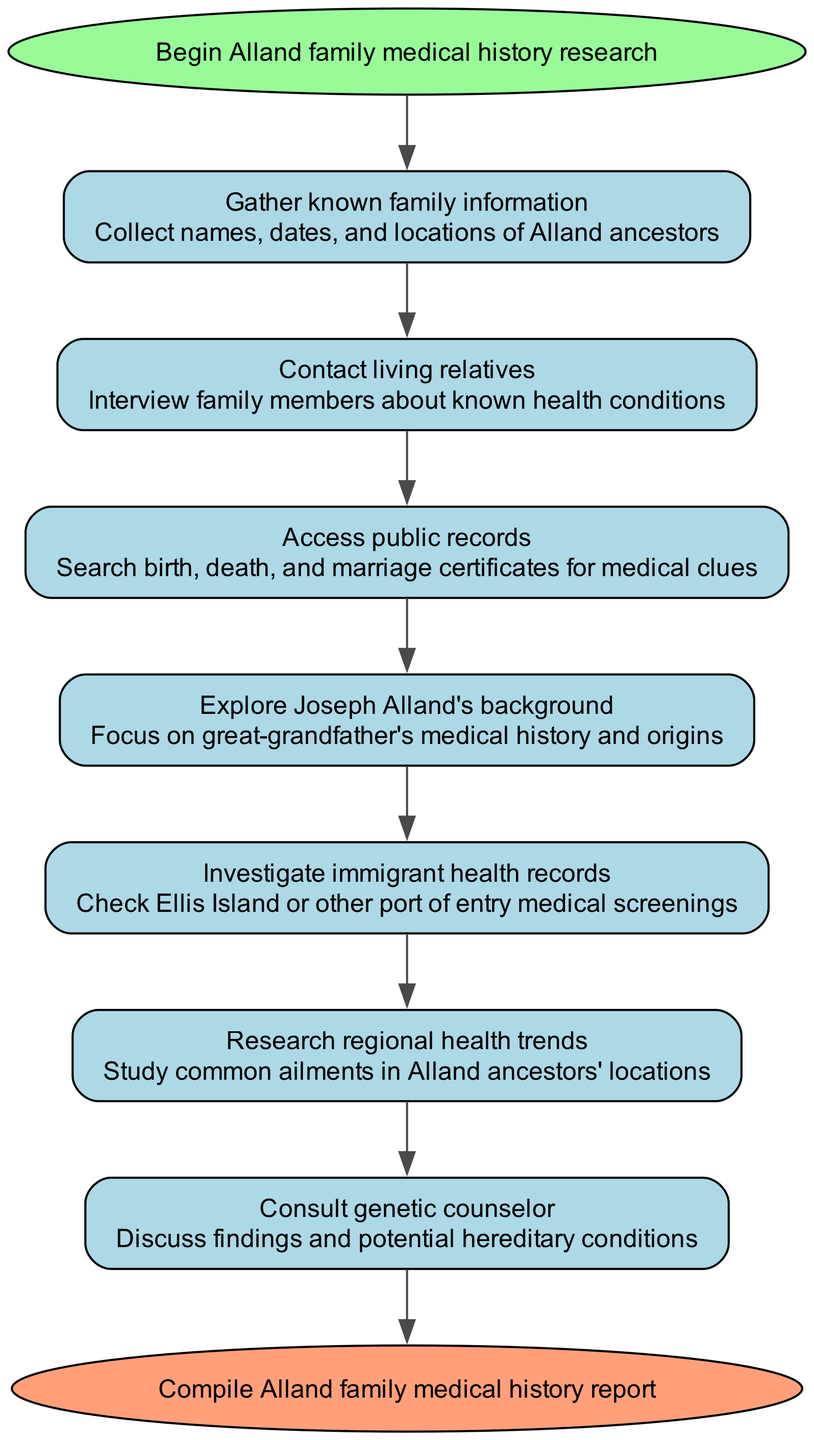What is the first step in the Alland family medical history research? The first step in the research as indicated in the diagram is "Gather known family information." This is the step that directly follows the start node of the pathway.
Answer: Gather known family information How many steps are there in total in the diagram? Counting the steps listed in the diagram, there are a total of 7 steps between the start and end nodes, not including the start and end nodes themselves.
Answer: 7 What step involves interviewing family members? The step that involves interviewing family members is "Contact living relatives," which is specifically detailed to gather information on known health conditions. This step is connected to the previous step of gathering known family information.
Answer: Contact living relatives What is the last step before compiling the medical history report? The last step before compiling the medical history report is "Consult genetic counselor." This indicates that before the final report is compiled, discussions of findings and potential hereditary conditions take place.
Answer: Consult genetic counselor Which step focuses on Joseph Alland's background? The step that focuses on Joseph Alland's background is "Explore Joseph Alland's background." This step is specifically aimed at understanding the medical history and origins associated with the great-grandfather.
Answer: Explore Joseph Alland's background What two steps are connected to understanding health trends in ancestors' locations? The two steps that are connected to understanding health trends are "Research regional health trends" and "Investigate immigrant health records." The first studies common ailments in locations where ancestors lived, while the second examines health screenings at points of entry, providing context to those health trends.
Answer: Research regional health trends; Investigate immigrant health records What is the purpose of accessing public records in this pathway? The purpose of accessing public records, as detailed in the diagram, is to "Search birth, death, and marriage certificates for medical clues." This action aims to uncover important medical details and patterns associated with the Alland family history.
Answer: Search birth, death, and marriage certificates for medical clues What health-related information might the step "Investigate immigrant health records" provide? The step "Investigate immigrant health records" may provide information regarding the medical screenings conducted at ports of entry like Ellis Island, which can reveal health conditions or issues the ancestors faced upon arrival.
Answer: Medical screenings at ports of entry 